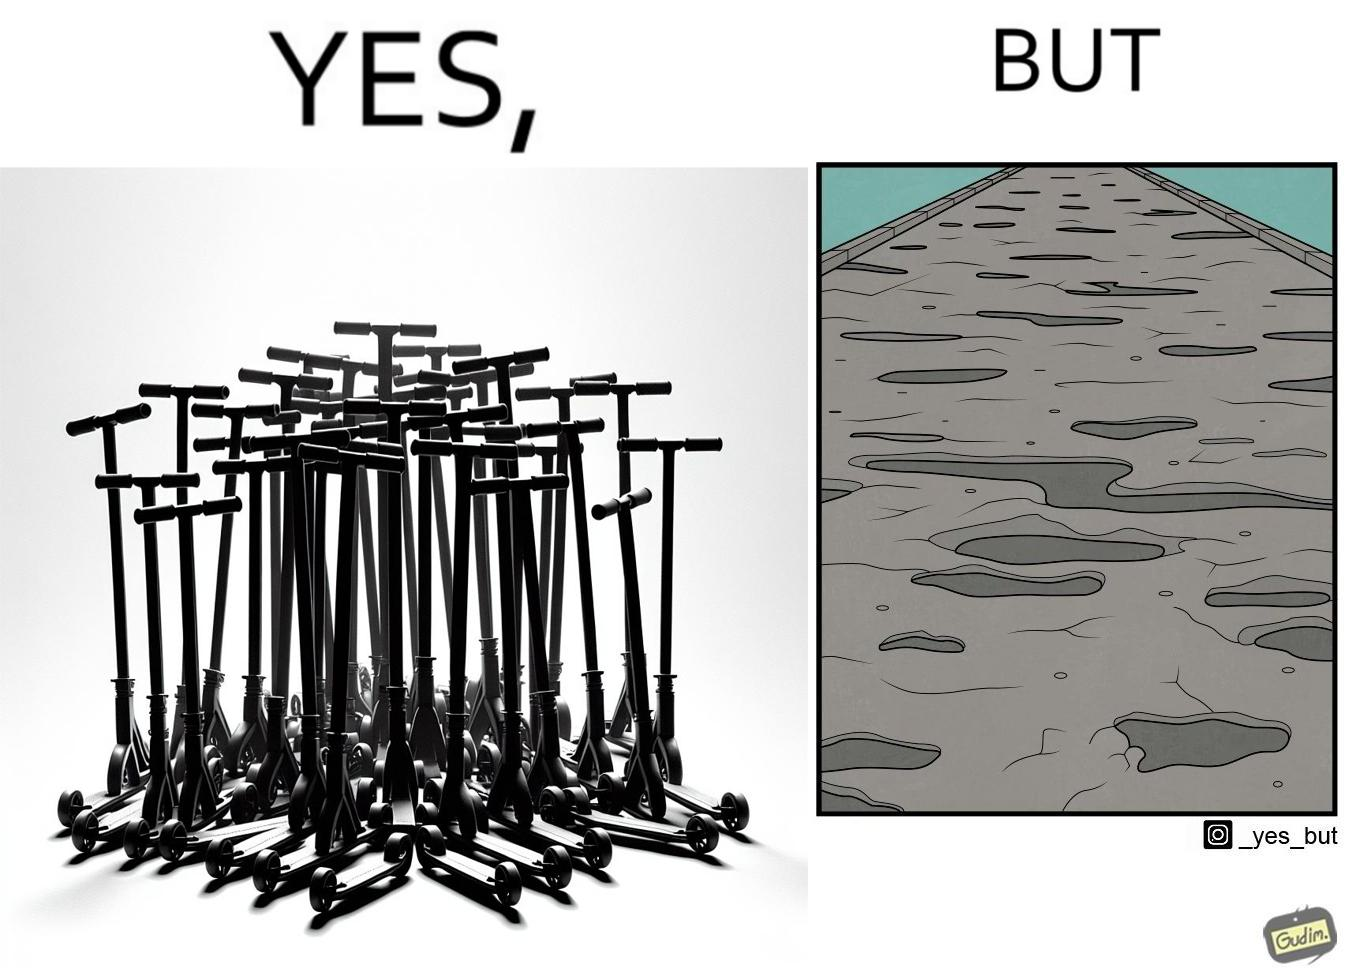Why is this image considered satirical? The image is ironic, because even after when the skateboard scooters are available for someone to ride but the road has many potholes that it is not suitable to ride the scooters on such roads 